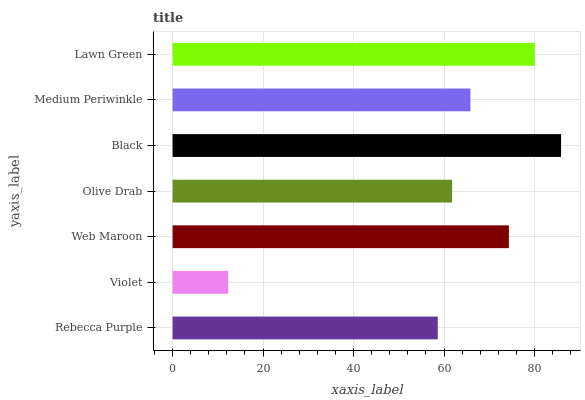Is Violet the minimum?
Answer yes or no. Yes. Is Black the maximum?
Answer yes or no. Yes. Is Web Maroon the minimum?
Answer yes or no. No. Is Web Maroon the maximum?
Answer yes or no. No. Is Web Maroon greater than Violet?
Answer yes or no. Yes. Is Violet less than Web Maroon?
Answer yes or no. Yes. Is Violet greater than Web Maroon?
Answer yes or no. No. Is Web Maroon less than Violet?
Answer yes or no. No. Is Medium Periwinkle the high median?
Answer yes or no. Yes. Is Medium Periwinkle the low median?
Answer yes or no. Yes. Is Web Maroon the high median?
Answer yes or no. No. Is Olive Drab the low median?
Answer yes or no. No. 